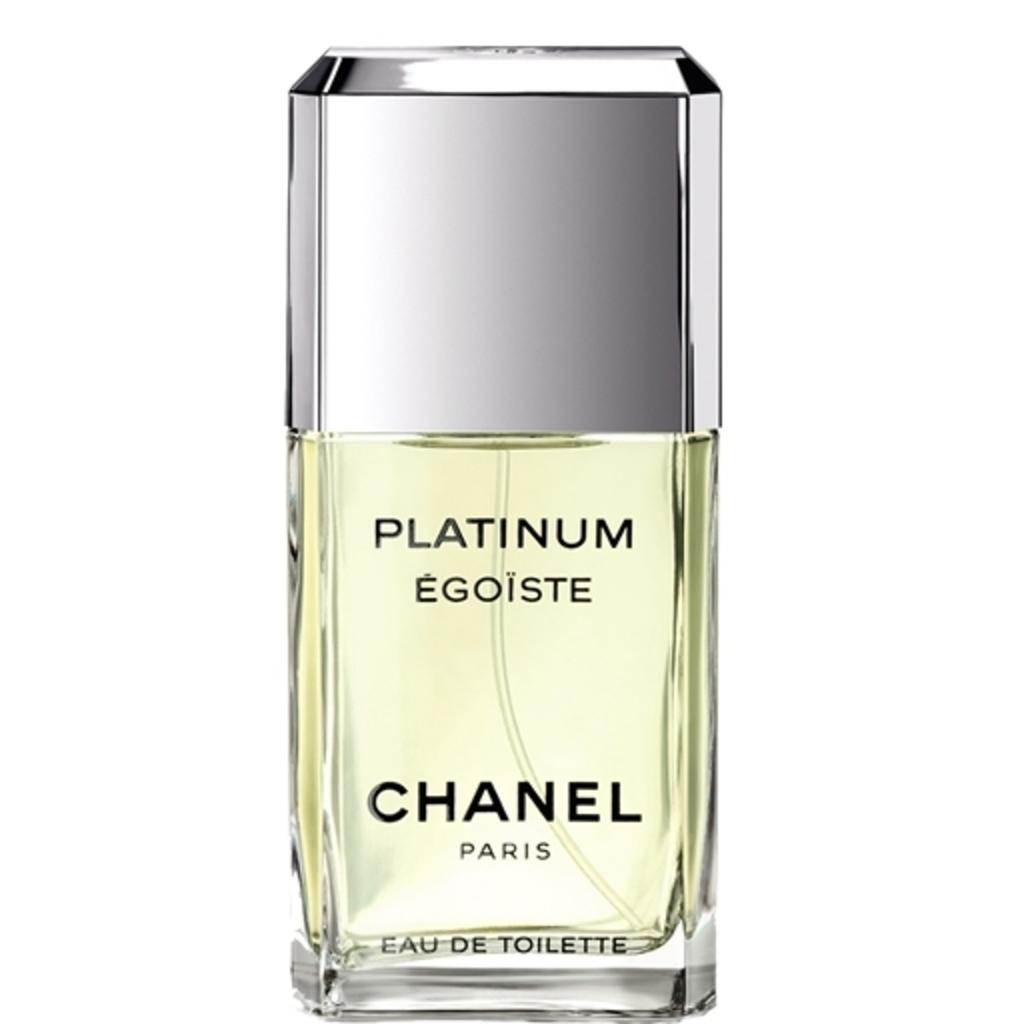Provide a one-sentence caption for the provided image. some chanel cologne with some platinum in it. 